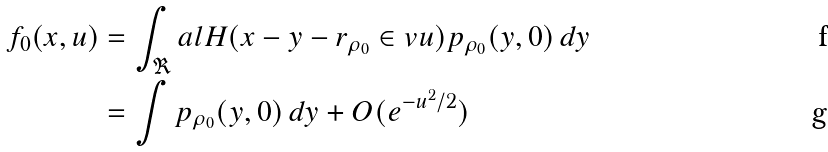<formula> <loc_0><loc_0><loc_500><loc_500>f _ { 0 } ( x , u ) & = \int _ { \Re } a l H ( x - y - r _ { \rho _ { 0 } } \in v u ) p _ { \rho _ { 0 } } ( y , 0 ) \, d y \\ & = \int p _ { \rho _ { 0 } } ( y , 0 ) \, d y + O ( e ^ { - u ^ { 2 } / 2 } )</formula> 